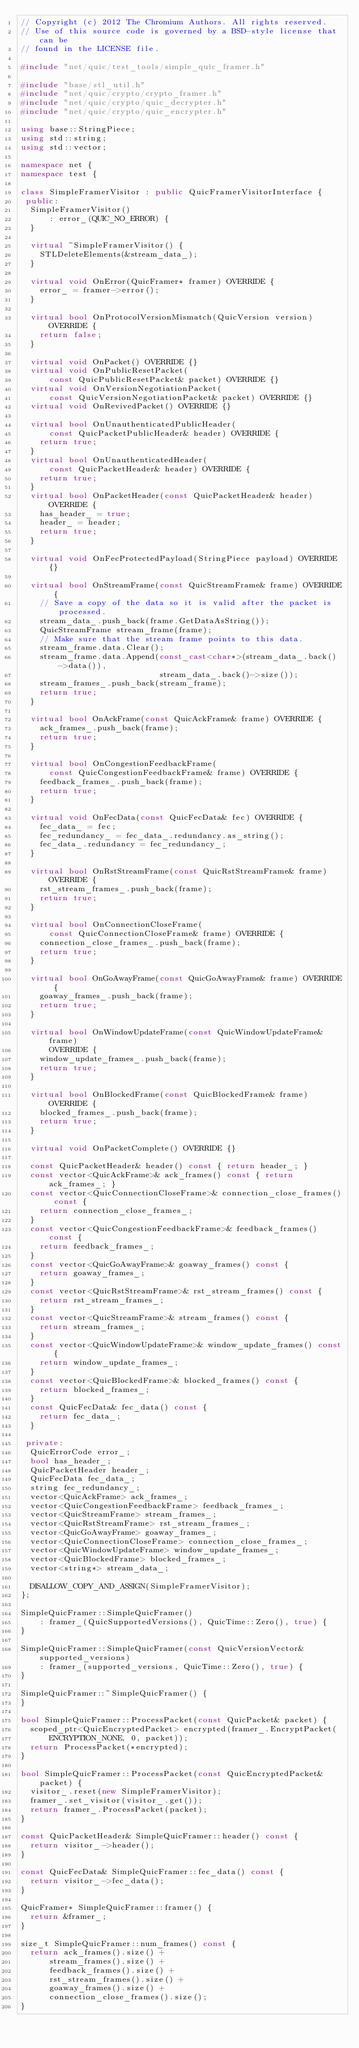Convert code to text. <code><loc_0><loc_0><loc_500><loc_500><_C++_>// Copyright (c) 2012 The Chromium Authors. All rights reserved.
// Use of this source code is governed by a BSD-style license that can be
// found in the LICENSE file.

#include "net/quic/test_tools/simple_quic_framer.h"

#include "base/stl_util.h"
#include "net/quic/crypto/crypto_framer.h"
#include "net/quic/crypto/quic_decrypter.h"
#include "net/quic/crypto/quic_encrypter.h"

using base::StringPiece;
using std::string;
using std::vector;

namespace net {
namespace test {

class SimpleFramerVisitor : public QuicFramerVisitorInterface {
 public:
  SimpleFramerVisitor()
      : error_(QUIC_NO_ERROR) {
  }

  virtual ~SimpleFramerVisitor() {
    STLDeleteElements(&stream_data_);
  }

  virtual void OnError(QuicFramer* framer) OVERRIDE {
    error_ = framer->error();
  }

  virtual bool OnProtocolVersionMismatch(QuicVersion version) OVERRIDE {
    return false;
  }

  virtual void OnPacket() OVERRIDE {}
  virtual void OnPublicResetPacket(
      const QuicPublicResetPacket& packet) OVERRIDE {}
  virtual void OnVersionNegotiationPacket(
      const QuicVersionNegotiationPacket& packet) OVERRIDE {}
  virtual void OnRevivedPacket() OVERRIDE {}

  virtual bool OnUnauthenticatedPublicHeader(
      const QuicPacketPublicHeader& header) OVERRIDE {
    return true;
  }
  virtual bool OnUnauthenticatedHeader(
      const QuicPacketHeader& header) OVERRIDE {
    return true;
  }
  virtual bool OnPacketHeader(const QuicPacketHeader& header) OVERRIDE {
    has_header_ = true;
    header_ = header;
    return true;
  }

  virtual void OnFecProtectedPayload(StringPiece payload) OVERRIDE {}

  virtual bool OnStreamFrame(const QuicStreamFrame& frame) OVERRIDE {
    // Save a copy of the data so it is valid after the packet is processed.
    stream_data_.push_back(frame.GetDataAsString());
    QuicStreamFrame stream_frame(frame);
    // Make sure that the stream frame points to this data.
    stream_frame.data.Clear();
    stream_frame.data.Append(const_cast<char*>(stream_data_.back()->data()),
                             stream_data_.back()->size());
    stream_frames_.push_back(stream_frame);
    return true;
  }

  virtual bool OnAckFrame(const QuicAckFrame& frame) OVERRIDE {
    ack_frames_.push_back(frame);
    return true;
  }

  virtual bool OnCongestionFeedbackFrame(
      const QuicCongestionFeedbackFrame& frame) OVERRIDE {
    feedback_frames_.push_back(frame);
    return true;
  }

  virtual void OnFecData(const QuicFecData& fec) OVERRIDE {
    fec_data_ = fec;
    fec_redundancy_ = fec_data_.redundancy.as_string();
    fec_data_.redundancy = fec_redundancy_;
  }

  virtual bool OnRstStreamFrame(const QuicRstStreamFrame& frame) OVERRIDE {
    rst_stream_frames_.push_back(frame);
    return true;
  }

  virtual bool OnConnectionCloseFrame(
      const QuicConnectionCloseFrame& frame) OVERRIDE {
    connection_close_frames_.push_back(frame);
    return true;
  }

  virtual bool OnGoAwayFrame(const QuicGoAwayFrame& frame) OVERRIDE {
    goaway_frames_.push_back(frame);
    return true;
  }

  virtual bool OnWindowUpdateFrame(const QuicWindowUpdateFrame& frame)
      OVERRIDE {
    window_update_frames_.push_back(frame);
    return true;
  }

  virtual bool OnBlockedFrame(const QuicBlockedFrame& frame) OVERRIDE {
    blocked_frames_.push_back(frame);
    return true;
  }

  virtual void OnPacketComplete() OVERRIDE {}

  const QuicPacketHeader& header() const { return header_; }
  const vector<QuicAckFrame>& ack_frames() const { return ack_frames_; }
  const vector<QuicConnectionCloseFrame>& connection_close_frames() const {
    return connection_close_frames_;
  }
  const vector<QuicCongestionFeedbackFrame>& feedback_frames() const {
    return feedback_frames_;
  }
  const vector<QuicGoAwayFrame>& goaway_frames() const {
    return goaway_frames_;
  }
  const vector<QuicRstStreamFrame>& rst_stream_frames() const {
    return rst_stream_frames_;
  }
  const vector<QuicStreamFrame>& stream_frames() const {
    return stream_frames_;
  }
  const vector<QuicWindowUpdateFrame>& window_update_frames() const {
    return window_update_frames_;
  }
  const vector<QuicBlockedFrame>& blocked_frames() const {
    return blocked_frames_;
  }
  const QuicFecData& fec_data() const {
    return fec_data_;
  }

 private:
  QuicErrorCode error_;
  bool has_header_;
  QuicPacketHeader header_;
  QuicFecData fec_data_;
  string fec_redundancy_;
  vector<QuicAckFrame> ack_frames_;
  vector<QuicCongestionFeedbackFrame> feedback_frames_;
  vector<QuicStreamFrame> stream_frames_;
  vector<QuicRstStreamFrame> rst_stream_frames_;
  vector<QuicGoAwayFrame> goaway_frames_;
  vector<QuicConnectionCloseFrame> connection_close_frames_;
  vector<QuicWindowUpdateFrame> window_update_frames_;
  vector<QuicBlockedFrame> blocked_frames_;
  vector<string*> stream_data_;

  DISALLOW_COPY_AND_ASSIGN(SimpleFramerVisitor);
};

SimpleQuicFramer::SimpleQuicFramer()
    : framer_(QuicSupportedVersions(), QuicTime::Zero(), true) {
}

SimpleQuicFramer::SimpleQuicFramer(const QuicVersionVector& supported_versions)
    : framer_(supported_versions, QuicTime::Zero(), true) {
}

SimpleQuicFramer::~SimpleQuicFramer() {
}

bool SimpleQuicFramer::ProcessPacket(const QuicPacket& packet) {
  scoped_ptr<QuicEncryptedPacket> encrypted(framer_.EncryptPacket(
      ENCRYPTION_NONE, 0, packet));
  return ProcessPacket(*encrypted);
}

bool SimpleQuicFramer::ProcessPacket(const QuicEncryptedPacket& packet) {
  visitor_.reset(new SimpleFramerVisitor);
  framer_.set_visitor(visitor_.get());
  return framer_.ProcessPacket(packet);
}

const QuicPacketHeader& SimpleQuicFramer::header() const {
  return visitor_->header();
}

const QuicFecData& SimpleQuicFramer::fec_data() const {
  return visitor_->fec_data();
}

QuicFramer* SimpleQuicFramer::framer() {
  return &framer_;
}

size_t SimpleQuicFramer::num_frames() const {
  return ack_frames().size() +
      stream_frames().size() +
      feedback_frames().size() +
      rst_stream_frames().size() +
      goaway_frames().size() +
      connection_close_frames().size();
}
</code> 